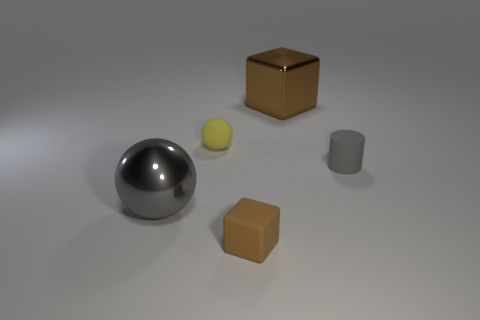What's the lighting like in this scene? The scene is softly illuminated from above, casting gentle shadows directly under each object, suggesting a diffuse light source. 